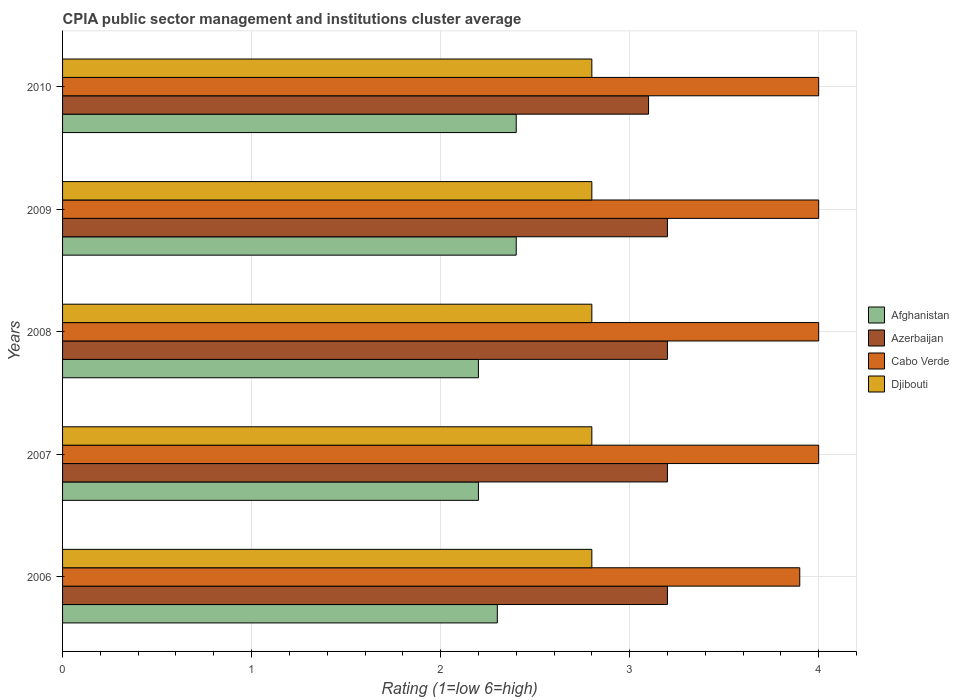Are the number of bars per tick equal to the number of legend labels?
Ensure brevity in your answer.  Yes. How many bars are there on the 4th tick from the top?
Offer a very short reply. 4. What is the label of the 3rd group of bars from the top?
Provide a succinct answer. 2008. In how many cases, is the number of bars for a given year not equal to the number of legend labels?
Offer a terse response. 0. Across all years, what is the minimum CPIA rating in Djibouti?
Give a very brief answer. 2.8. What is the difference between the CPIA rating in Djibouti in 2006 and the CPIA rating in Cabo Verde in 2009?
Make the answer very short. -1.2. What is the average CPIA rating in Cabo Verde per year?
Give a very brief answer. 3.98. In the year 2010, what is the difference between the CPIA rating in Cabo Verde and CPIA rating in Afghanistan?
Keep it short and to the point. 1.6. What is the ratio of the CPIA rating in Azerbaijan in 2006 to that in 2008?
Make the answer very short. 1. What is the difference between the highest and the lowest CPIA rating in Afghanistan?
Your answer should be compact. 0.2. Is it the case that in every year, the sum of the CPIA rating in Afghanistan and CPIA rating in Azerbaijan is greater than the sum of CPIA rating in Cabo Verde and CPIA rating in Djibouti?
Make the answer very short. Yes. What does the 3rd bar from the top in 2009 represents?
Your response must be concise. Azerbaijan. What does the 3rd bar from the bottom in 2007 represents?
Give a very brief answer. Cabo Verde. Is it the case that in every year, the sum of the CPIA rating in Djibouti and CPIA rating in Azerbaijan is greater than the CPIA rating in Afghanistan?
Give a very brief answer. Yes. How many years are there in the graph?
Offer a terse response. 5. What is the difference between two consecutive major ticks on the X-axis?
Make the answer very short. 1. Where does the legend appear in the graph?
Provide a succinct answer. Center right. What is the title of the graph?
Make the answer very short. CPIA public sector management and institutions cluster average. What is the Rating (1=low 6=high) in Afghanistan in 2006?
Make the answer very short. 2.3. What is the Rating (1=low 6=high) of Azerbaijan in 2006?
Ensure brevity in your answer.  3.2. What is the Rating (1=low 6=high) in Azerbaijan in 2007?
Your response must be concise. 3.2. What is the Rating (1=low 6=high) in Cabo Verde in 2007?
Ensure brevity in your answer.  4. What is the Rating (1=low 6=high) of Afghanistan in 2008?
Your answer should be very brief. 2.2. What is the Rating (1=low 6=high) in Azerbaijan in 2009?
Make the answer very short. 3.2. What is the Rating (1=low 6=high) in Cabo Verde in 2010?
Offer a terse response. 4. Across all years, what is the maximum Rating (1=low 6=high) in Afghanistan?
Ensure brevity in your answer.  2.4. Across all years, what is the minimum Rating (1=low 6=high) of Azerbaijan?
Make the answer very short. 3.1. Across all years, what is the minimum Rating (1=low 6=high) of Djibouti?
Give a very brief answer. 2.8. What is the total Rating (1=low 6=high) in Afghanistan in the graph?
Your answer should be very brief. 11.5. What is the total Rating (1=low 6=high) in Azerbaijan in the graph?
Provide a short and direct response. 15.9. What is the total Rating (1=low 6=high) in Cabo Verde in the graph?
Offer a terse response. 19.9. What is the difference between the Rating (1=low 6=high) in Afghanistan in 2006 and that in 2007?
Ensure brevity in your answer.  0.1. What is the difference between the Rating (1=low 6=high) in Azerbaijan in 2006 and that in 2007?
Offer a terse response. 0. What is the difference between the Rating (1=low 6=high) in Azerbaijan in 2006 and that in 2008?
Give a very brief answer. 0. What is the difference between the Rating (1=low 6=high) of Cabo Verde in 2006 and that in 2008?
Make the answer very short. -0.1. What is the difference between the Rating (1=low 6=high) in Azerbaijan in 2006 and that in 2009?
Your answer should be very brief. 0. What is the difference between the Rating (1=low 6=high) of Cabo Verde in 2006 and that in 2009?
Give a very brief answer. -0.1. What is the difference between the Rating (1=low 6=high) of Azerbaijan in 2006 and that in 2010?
Ensure brevity in your answer.  0.1. What is the difference between the Rating (1=low 6=high) in Djibouti in 2006 and that in 2010?
Your response must be concise. 0. What is the difference between the Rating (1=low 6=high) in Afghanistan in 2007 and that in 2008?
Your answer should be very brief. 0. What is the difference between the Rating (1=low 6=high) in Azerbaijan in 2007 and that in 2008?
Offer a very short reply. 0. What is the difference between the Rating (1=low 6=high) in Cabo Verde in 2007 and that in 2008?
Your answer should be compact. 0. What is the difference between the Rating (1=low 6=high) in Djibouti in 2007 and that in 2008?
Keep it short and to the point. 0. What is the difference between the Rating (1=low 6=high) of Azerbaijan in 2007 and that in 2009?
Offer a terse response. 0. What is the difference between the Rating (1=low 6=high) of Cabo Verde in 2007 and that in 2009?
Your response must be concise. 0. What is the difference between the Rating (1=low 6=high) in Djibouti in 2007 and that in 2009?
Keep it short and to the point. 0. What is the difference between the Rating (1=low 6=high) of Afghanistan in 2007 and that in 2010?
Make the answer very short. -0.2. What is the difference between the Rating (1=low 6=high) in Azerbaijan in 2007 and that in 2010?
Your response must be concise. 0.1. What is the difference between the Rating (1=low 6=high) in Cabo Verde in 2007 and that in 2010?
Provide a short and direct response. 0. What is the difference between the Rating (1=low 6=high) in Azerbaijan in 2008 and that in 2009?
Ensure brevity in your answer.  0. What is the difference between the Rating (1=low 6=high) of Djibouti in 2008 and that in 2009?
Ensure brevity in your answer.  0. What is the difference between the Rating (1=low 6=high) in Afghanistan in 2008 and that in 2010?
Provide a succinct answer. -0.2. What is the difference between the Rating (1=low 6=high) of Azerbaijan in 2008 and that in 2010?
Ensure brevity in your answer.  0.1. What is the difference between the Rating (1=low 6=high) of Afghanistan in 2009 and that in 2010?
Your answer should be very brief. 0. What is the difference between the Rating (1=low 6=high) of Azerbaijan in 2009 and that in 2010?
Your response must be concise. 0.1. What is the difference between the Rating (1=low 6=high) in Cabo Verde in 2009 and that in 2010?
Ensure brevity in your answer.  0. What is the difference between the Rating (1=low 6=high) in Djibouti in 2009 and that in 2010?
Provide a succinct answer. 0. What is the difference between the Rating (1=low 6=high) in Afghanistan in 2006 and the Rating (1=low 6=high) in Cabo Verde in 2007?
Your answer should be very brief. -1.7. What is the difference between the Rating (1=low 6=high) in Afghanistan in 2006 and the Rating (1=low 6=high) in Azerbaijan in 2008?
Give a very brief answer. -0.9. What is the difference between the Rating (1=low 6=high) in Afghanistan in 2006 and the Rating (1=low 6=high) in Djibouti in 2008?
Ensure brevity in your answer.  -0.5. What is the difference between the Rating (1=low 6=high) in Azerbaijan in 2006 and the Rating (1=low 6=high) in Cabo Verde in 2008?
Your answer should be compact. -0.8. What is the difference between the Rating (1=low 6=high) of Azerbaijan in 2006 and the Rating (1=low 6=high) of Djibouti in 2008?
Ensure brevity in your answer.  0.4. What is the difference between the Rating (1=low 6=high) of Afghanistan in 2006 and the Rating (1=low 6=high) of Azerbaijan in 2009?
Your answer should be compact. -0.9. What is the difference between the Rating (1=low 6=high) of Azerbaijan in 2006 and the Rating (1=low 6=high) of Cabo Verde in 2009?
Keep it short and to the point. -0.8. What is the difference between the Rating (1=low 6=high) of Afghanistan in 2006 and the Rating (1=low 6=high) of Azerbaijan in 2010?
Offer a very short reply. -0.8. What is the difference between the Rating (1=low 6=high) of Afghanistan in 2006 and the Rating (1=low 6=high) of Djibouti in 2010?
Your answer should be compact. -0.5. What is the difference between the Rating (1=low 6=high) in Cabo Verde in 2006 and the Rating (1=low 6=high) in Djibouti in 2010?
Offer a terse response. 1.1. What is the difference between the Rating (1=low 6=high) of Afghanistan in 2007 and the Rating (1=low 6=high) of Azerbaijan in 2008?
Make the answer very short. -1. What is the difference between the Rating (1=low 6=high) of Afghanistan in 2007 and the Rating (1=low 6=high) of Djibouti in 2008?
Ensure brevity in your answer.  -0.6. What is the difference between the Rating (1=low 6=high) in Azerbaijan in 2007 and the Rating (1=low 6=high) in Cabo Verde in 2008?
Your answer should be compact. -0.8. What is the difference between the Rating (1=low 6=high) in Azerbaijan in 2007 and the Rating (1=low 6=high) in Djibouti in 2008?
Offer a terse response. 0.4. What is the difference between the Rating (1=low 6=high) in Afghanistan in 2007 and the Rating (1=low 6=high) in Djibouti in 2009?
Your answer should be compact. -0.6. What is the difference between the Rating (1=low 6=high) of Azerbaijan in 2007 and the Rating (1=low 6=high) of Djibouti in 2009?
Your answer should be compact. 0.4. What is the difference between the Rating (1=low 6=high) of Afghanistan in 2007 and the Rating (1=low 6=high) of Azerbaijan in 2010?
Provide a short and direct response. -0.9. What is the difference between the Rating (1=low 6=high) in Afghanistan in 2007 and the Rating (1=low 6=high) in Djibouti in 2010?
Offer a terse response. -0.6. What is the difference between the Rating (1=low 6=high) in Afghanistan in 2008 and the Rating (1=low 6=high) in Cabo Verde in 2009?
Keep it short and to the point. -1.8. What is the difference between the Rating (1=low 6=high) in Azerbaijan in 2008 and the Rating (1=low 6=high) in Cabo Verde in 2009?
Provide a short and direct response. -0.8. What is the difference between the Rating (1=low 6=high) of Azerbaijan in 2008 and the Rating (1=low 6=high) of Djibouti in 2009?
Your answer should be compact. 0.4. What is the difference between the Rating (1=low 6=high) of Cabo Verde in 2008 and the Rating (1=low 6=high) of Djibouti in 2009?
Your response must be concise. 1.2. What is the difference between the Rating (1=low 6=high) in Afghanistan in 2008 and the Rating (1=low 6=high) in Cabo Verde in 2010?
Keep it short and to the point. -1.8. What is the difference between the Rating (1=low 6=high) in Azerbaijan in 2008 and the Rating (1=low 6=high) in Cabo Verde in 2010?
Offer a very short reply. -0.8. What is the difference between the Rating (1=low 6=high) in Azerbaijan in 2008 and the Rating (1=low 6=high) in Djibouti in 2010?
Provide a short and direct response. 0.4. What is the difference between the Rating (1=low 6=high) of Afghanistan in 2009 and the Rating (1=low 6=high) of Azerbaijan in 2010?
Provide a succinct answer. -0.7. What is the difference between the Rating (1=low 6=high) of Afghanistan in 2009 and the Rating (1=low 6=high) of Cabo Verde in 2010?
Make the answer very short. -1.6. What is the difference between the Rating (1=low 6=high) in Azerbaijan in 2009 and the Rating (1=low 6=high) in Cabo Verde in 2010?
Your answer should be compact. -0.8. What is the difference between the Rating (1=low 6=high) of Cabo Verde in 2009 and the Rating (1=low 6=high) of Djibouti in 2010?
Offer a very short reply. 1.2. What is the average Rating (1=low 6=high) in Afghanistan per year?
Offer a very short reply. 2.3. What is the average Rating (1=low 6=high) in Azerbaijan per year?
Your answer should be compact. 3.18. What is the average Rating (1=low 6=high) of Cabo Verde per year?
Keep it short and to the point. 3.98. In the year 2006, what is the difference between the Rating (1=low 6=high) of Afghanistan and Rating (1=low 6=high) of Azerbaijan?
Make the answer very short. -0.9. In the year 2006, what is the difference between the Rating (1=low 6=high) in Afghanistan and Rating (1=low 6=high) in Cabo Verde?
Provide a short and direct response. -1.6. In the year 2006, what is the difference between the Rating (1=low 6=high) of Afghanistan and Rating (1=low 6=high) of Djibouti?
Offer a terse response. -0.5. In the year 2006, what is the difference between the Rating (1=low 6=high) in Azerbaijan and Rating (1=low 6=high) in Djibouti?
Offer a very short reply. 0.4. In the year 2007, what is the difference between the Rating (1=low 6=high) of Afghanistan and Rating (1=low 6=high) of Djibouti?
Provide a short and direct response. -0.6. In the year 2007, what is the difference between the Rating (1=low 6=high) of Cabo Verde and Rating (1=low 6=high) of Djibouti?
Make the answer very short. 1.2. In the year 2008, what is the difference between the Rating (1=low 6=high) in Afghanistan and Rating (1=low 6=high) in Azerbaijan?
Offer a terse response. -1. In the year 2008, what is the difference between the Rating (1=low 6=high) of Afghanistan and Rating (1=low 6=high) of Cabo Verde?
Offer a terse response. -1.8. In the year 2008, what is the difference between the Rating (1=low 6=high) in Azerbaijan and Rating (1=low 6=high) in Cabo Verde?
Offer a terse response. -0.8. In the year 2008, what is the difference between the Rating (1=low 6=high) of Cabo Verde and Rating (1=low 6=high) of Djibouti?
Keep it short and to the point. 1.2. In the year 2009, what is the difference between the Rating (1=low 6=high) in Afghanistan and Rating (1=low 6=high) in Cabo Verde?
Keep it short and to the point. -1.6. In the year 2009, what is the difference between the Rating (1=low 6=high) of Afghanistan and Rating (1=low 6=high) of Djibouti?
Offer a very short reply. -0.4. In the year 2009, what is the difference between the Rating (1=low 6=high) in Azerbaijan and Rating (1=low 6=high) in Cabo Verde?
Offer a very short reply. -0.8. In the year 2009, what is the difference between the Rating (1=low 6=high) in Cabo Verde and Rating (1=low 6=high) in Djibouti?
Give a very brief answer. 1.2. In the year 2010, what is the difference between the Rating (1=low 6=high) in Afghanistan and Rating (1=low 6=high) in Azerbaijan?
Offer a very short reply. -0.7. In the year 2010, what is the difference between the Rating (1=low 6=high) in Afghanistan and Rating (1=low 6=high) in Djibouti?
Offer a terse response. -0.4. In the year 2010, what is the difference between the Rating (1=low 6=high) in Azerbaijan and Rating (1=low 6=high) in Djibouti?
Ensure brevity in your answer.  0.3. What is the ratio of the Rating (1=low 6=high) in Afghanistan in 2006 to that in 2007?
Make the answer very short. 1.05. What is the ratio of the Rating (1=low 6=high) in Djibouti in 2006 to that in 2007?
Provide a succinct answer. 1. What is the ratio of the Rating (1=low 6=high) in Afghanistan in 2006 to that in 2008?
Make the answer very short. 1.05. What is the ratio of the Rating (1=low 6=high) in Cabo Verde in 2006 to that in 2008?
Keep it short and to the point. 0.97. What is the ratio of the Rating (1=low 6=high) in Djibouti in 2006 to that in 2008?
Give a very brief answer. 1. What is the ratio of the Rating (1=low 6=high) of Afghanistan in 2006 to that in 2009?
Your answer should be very brief. 0.96. What is the ratio of the Rating (1=low 6=high) of Cabo Verde in 2006 to that in 2009?
Your answer should be very brief. 0.97. What is the ratio of the Rating (1=low 6=high) of Afghanistan in 2006 to that in 2010?
Offer a very short reply. 0.96. What is the ratio of the Rating (1=low 6=high) of Azerbaijan in 2006 to that in 2010?
Provide a short and direct response. 1.03. What is the ratio of the Rating (1=low 6=high) in Djibouti in 2006 to that in 2010?
Your answer should be compact. 1. What is the ratio of the Rating (1=low 6=high) in Cabo Verde in 2007 to that in 2008?
Give a very brief answer. 1. What is the ratio of the Rating (1=low 6=high) of Azerbaijan in 2007 to that in 2009?
Offer a very short reply. 1. What is the ratio of the Rating (1=low 6=high) in Afghanistan in 2007 to that in 2010?
Offer a terse response. 0.92. What is the ratio of the Rating (1=low 6=high) in Azerbaijan in 2007 to that in 2010?
Give a very brief answer. 1.03. What is the ratio of the Rating (1=low 6=high) in Cabo Verde in 2007 to that in 2010?
Provide a short and direct response. 1. What is the ratio of the Rating (1=low 6=high) in Djibouti in 2007 to that in 2010?
Give a very brief answer. 1. What is the ratio of the Rating (1=low 6=high) of Afghanistan in 2008 to that in 2009?
Provide a short and direct response. 0.92. What is the ratio of the Rating (1=low 6=high) in Azerbaijan in 2008 to that in 2009?
Provide a succinct answer. 1. What is the ratio of the Rating (1=low 6=high) in Afghanistan in 2008 to that in 2010?
Give a very brief answer. 0.92. What is the ratio of the Rating (1=low 6=high) of Azerbaijan in 2008 to that in 2010?
Provide a short and direct response. 1.03. What is the ratio of the Rating (1=low 6=high) in Cabo Verde in 2008 to that in 2010?
Offer a terse response. 1. What is the ratio of the Rating (1=low 6=high) in Afghanistan in 2009 to that in 2010?
Provide a succinct answer. 1. What is the ratio of the Rating (1=low 6=high) of Azerbaijan in 2009 to that in 2010?
Make the answer very short. 1.03. What is the ratio of the Rating (1=low 6=high) of Djibouti in 2009 to that in 2010?
Give a very brief answer. 1. What is the difference between the highest and the second highest Rating (1=low 6=high) in Djibouti?
Offer a terse response. 0. What is the difference between the highest and the lowest Rating (1=low 6=high) of Azerbaijan?
Provide a short and direct response. 0.1. What is the difference between the highest and the lowest Rating (1=low 6=high) in Cabo Verde?
Keep it short and to the point. 0.1. What is the difference between the highest and the lowest Rating (1=low 6=high) of Djibouti?
Offer a very short reply. 0. 